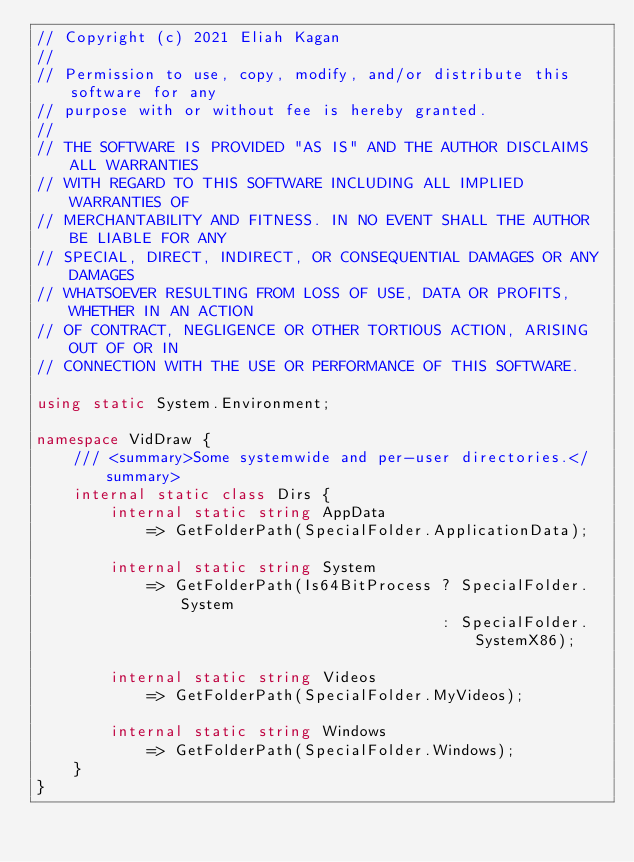<code> <loc_0><loc_0><loc_500><loc_500><_C#_>// Copyright (c) 2021 Eliah Kagan
//
// Permission to use, copy, modify, and/or distribute this software for any
// purpose with or without fee is hereby granted.
//
// THE SOFTWARE IS PROVIDED "AS IS" AND THE AUTHOR DISCLAIMS ALL WARRANTIES
// WITH REGARD TO THIS SOFTWARE INCLUDING ALL IMPLIED WARRANTIES OF
// MERCHANTABILITY AND FITNESS. IN NO EVENT SHALL THE AUTHOR BE LIABLE FOR ANY
// SPECIAL, DIRECT, INDIRECT, OR CONSEQUENTIAL DAMAGES OR ANY DAMAGES
// WHATSOEVER RESULTING FROM LOSS OF USE, DATA OR PROFITS, WHETHER IN AN ACTION
// OF CONTRACT, NEGLIGENCE OR OTHER TORTIOUS ACTION, ARISING OUT OF OR IN
// CONNECTION WITH THE USE OR PERFORMANCE OF THIS SOFTWARE.

using static System.Environment;

namespace VidDraw {
    /// <summary>Some systemwide and per-user directories.</summary>
    internal static class Dirs {
        internal static string AppData
            => GetFolderPath(SpecialFolder.ApplicationData);

        internal static string System
            => GetFolderPath(Is64BitProcess ? SpecialFolder.System
                                            : SpecialFolder.SystemX86);

        internal static string Videos
            => GetFolderPath(SpecialFolder.MyVideos);

        internal static string Windows
            => GetFolderPath(SpecialFolder.Windows);
    }
}
</code> 